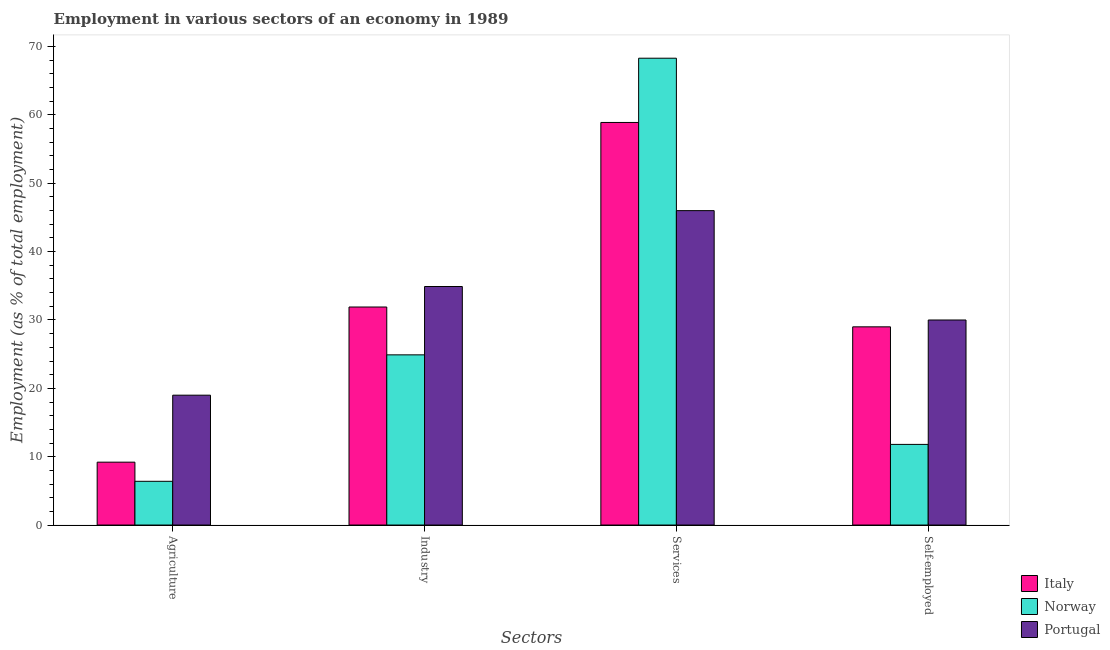Are the number of bars per tick equal to the number of legend labels?
Your response must be concise. Yes. How many bars are there on the 1st tick from the right?
Your answer should be very brief. 3. What is the label of the 3rd group of bars from the left?
Your response must be concise. Services. What is the percentage of self employed workers in Portugal?
Provide a succinct answer. 30. Across all countries, what is the maximum percentage of workers in industry?
Provide a succinct answer. 34.9. Across all countries, what is the minimum percentage of workers in agriculture?
Ensure brevity in your answer.  6.4. In which country was the percentage of workers in services maximum?
Your response must be concise. Norway. What is the total percentage of workers in industry in the graph?
Ensure brevity in your answer.  91.7. What is the difference between the percentage of workers in industry in Italy and that in Portugal?
Keep it short and to the point. -3. What is the difference between the percentage of workers in services in Portugal and the percentage of self employed workers in Italy?
Provide a short and direct response. 17. What is the average percentage of workers in agriculture per country?
Provide a short and direct response. 11.53. What is the difference between the percentage of workers in agriculture and percentage of workers in services in Portugal?
Offer a very short reply. -27. What is the ratio of the percentage of workers in industry in Norway to that in Italy?
Ensure brevity in your answer.  0.78. Is the percentage of workers in services in Norway less than that in Portugal?
Offer a terse response. No. Is the difference between the percentage of workers in agriculture in Norway and Italy greater than the difference between the percentage of workers in industry in Norway and Italy?
Make the answer very short. Yes. What is the difference between the highest and the second highest percentage of workers in services?
Offer a very short reply. 9.4. What is the difference between the highest and the lowest percentage of workers in services?
Offer a terse response. 22.3. What does the 3rd bar from the right in Agriculture represents?
Provide a short and direct response. Italy. Is it the case that in every country, the sum of the percentage of workers in agriculture and percentage of workers in industry is greater than the percentage of workers in services?
Give a very brief answer. No. What is the difference between two consecutive major ticks on the Y-axis?
Ensure brevity in your answer.  10. Are the values on the major ticks of Y-axis written in scientific E-notation?
Your response must be concise. No. Does the graph contain grids?
Your answer should be very brief. No. Where does the legend appear in the graph?
Offer a very short reply. Bottom right. What is the title of the graph?
Ensure brevity in your answer.  Employment in various sectors of an economy in 1989. What is the label or title of the X-axis?
Your answer should be very brief. Sectors. What is the label or title of the Y-axis?
Make the answer very short. Employment (as % of total employment). What is the Employment (as % of total employment) of Italy in Agriculture?
Offer a very short reply. 9.2. What is the Employment (as % of total employment) in Norway in Agriculture?
Offer a very short reply. 6.4. What is the Employment (as % of total employment) of Italy in Industry?
Offer a very short reply. 31.9. What is the Employment (as % of total employment) of Norway in Industry?
Give a very brief answer. 24.9. What is the Employment (as % of total employment) in Portugal in Industry?
Provide a short and direct response. 34.9. What is the Employment (as % of total employment) of Italy in Services?
Ensure brevity in your answer.  58.9. What is the Employment (as % of total employment) of Norway in Services?
Make the answer very short. 68.3. What is the Employment (as % of total employment) in Portugal in Services?
Provide a short and direct response. 46. What is the Employment (as % of total employment) in Italy in Self-employed?
Provide a short and direct response. 29. What is the Employment (as % of total employment) in Norway in Self-employed?
Offer a very short reply. 11.8. Across all Sectors, what is the maximum Employment (as % of total employment) of Italy?
Provide a short and direct response. 58.9. Across all Sectors, what is the maximum Employment (as % of total employment) in Norway?
Keep it short and to the point. 68.3. Across all Sectors, what is the maximum Employment (as % of total employment) of Portugal?
Offer a very short reply. 46. Across all Sectors, what is the minimum Employment (as % of total employment) of Italy?
Offer a very short reply. 9.2. Across all Sectors, what is the minimum Employment (as % of total employment) of Norway?
Keep it short and to the point. 6.4. What is the total Employment (as % of total employment) in Italy in the graph?
Provide a short and direct response. 129. What is the total Employment (as % of total employment) of Norway in the graph?
Make the answer very short. 111.4. What is the total Employment (as % of total employment) in Portugal in the graph?
Make the answer very short. 129.9. What is the difference between the Employment (as % of total employment) of Italy in Agriculture and that in Industry?
Offer a terse response. -22.7. What is the difference between the Employment (as % of total employment) of Norway in Agriculture and that in Industry?
Your response must be concise. -18.5. What is the difference between the Employment (as % of total employment) in Portugal in Agriculture and that in Industry?
Offer a very short reply. -15.9. What is the difference between the Employment (as % of total employment) in Italy in Agriculture and that in Services?
Offer a very short reply. -49.7. What is the difference between the Employment (as % of total employment) of Norway in Agriculture and that in Services?
Keep it short and to the point. -61.9. What is the difference between the Employment (as % of total employment) of Italy in Agriculture and that in Self-employed?
Your answer should be compact. -19.8. What is the difference between the Employment (as % of total employment) in Portugal in Agriculture and that in Self-employed?
Your answer should be compact. -11. What is the difference between the Employment (as % of total employment) of Norway in Industry and that in Services?
Offer a very short reply. -43.4. What is the difference between the Employment (as % of total employment) in Portugal in Industry and that in Services?
Your answer should be compact. -11.1. What is the difference between the Employment (as % of total employment) in Italy in Industry and that in Self-employed?
Provide a short and direct response. 2.9. What is the difference between the Employment (as % of total employment) in Italy in Services and that in Self-employed?
Offer a very short reply. 29.9. What is the difference between the Employment (as % of total employment) of Norway in Services and that in Self-employed?
Offer a terse response. 56.5. What is the difference between the Employment (as % of total employment) of Portugal in Services and that in Self-employed?
Offer a terse response. 16. What is the difference between the Employment (as % of total employment) of Italy in Agriculture and the Employment (as % of total employment) of Norway in Industry?
Make the answer very short. -15.7. What is the difference between the Employment (as % of total employment) in Italy in Agriculture and the Employment (as % of total employment) in Portugal in Industry?
Keep it short and to the point. -25.7. What is the difference between the Employment (as % of total employment) of Norway in Agriculture and the Employment (as % of total employment) of Portugal in Industry?
Your response must be concise. -28.5. What is the difference between the Employment (as % of total employment) in Italy in Agriculture and the Employment (as % of total employment) in Norway in Services?
Offer a terse response. -59.1. What is the difference between the Employment (as % of total employment) of Italy in Agriculture and the Employment (as % of total employment) of Portugal in Services?
Your response must be concise. -36.8. What is the difference between the Employment (as % of total employment) of Norway in Agriculture and the Employment (as % of total employment) of Portugal in Services?
Provide a succinct answer. -39.6. What is the difference between the Employment (as % of total employment) of Italy in Agriculture and the Employment (as % of total employment) of Norway in Self-employed?
Ensure brevity in your answer.  -2.6. What is the difference between the Employment (as % of total employment) in Italy in Agriculture and the Employment (as % of total employment) in Portugal in Self-employed?
Your answer should be very brief. -20.8. What is the difference between the Employment (as % of total employment) in Norway in Agriculture and the Employment (as % of total employment) in Portugal in Self-employed?
Provide a short and direct response. -23.6. What is the difference between the Employment (as % of total employment) of Italy in Industry and the Employment (as % of total employment) of Norway in Services?
Ensure brevity in your answer.  -36.4. What is the difference between the Employment (as % of total employment) of Italy in Industry and the Employment (as % of total employment) of Portugal in Services?
Your answer should be compact. -14.1. What is the difference between the Employment (as % of total employment) in Norway in Industry and the Employment (as % of total employment) in Portugal in Services?
Your response must be concise. -21.1. What is the difference between the Employment (as % of total employment) in Italy in Industry and the Employment (as % of total employment) in Norway in Self-employed?
Offer a very short reply. 20.1. What is the difference between the Employment (as % of total employment) in Italy in Services and the Employment (as % of total employment) in Norway in Self-employed?
Keep it short and to the point. 47.1. What is the difference between the Employment (as % of total employment) in Italy in Services and the Employment (as % of total employment) in Portugal in Self-employed?
Provide a short and direct response. 28.9. What is the difference between the Employment (as % of total employment) in Norway in Services and the Employment (as % of total employment) in Portugal in Self-employed?
Offer a very short reply. 38.3. What is the average Employment (as % of total employment) in Italy per Sectors?
Provide a short and direct response. 32.25. What is the average Employment (as % of total employment) in Norway per Sectors?
Keep it short and to the point. 27.85. What is the average Employment (as % of total employment) of Portugal per Sectors?
Your answer should be very brief. 32.48. What is the difference between the Employment (as % of total employment) in Italy and Employment (as % of total employment) in Portugal in Agriculture?
Ensure brevity in your answer.  -9.8. What is the difference between the Employment (as % of total employment) in Italy and Employment (as % of total employment) in Norway in Industry?
Your answer should be very brief. 7. What is the difference between the Employment (as % of total employment) of Norway and Employment (as % of total employment) of Portugal in Industry?
Offer a terse response. -10. What is the difference between the Employment (as % of total employment) of Italy and Employment (as % of total employment) of Portugal in Services?
Ensure brevity in your answer.  12.9. What is the difference between the Employment (as % of total employment) in Norway and Employment (as % of total employment) in Portugal in Services?
Ensure brevity in your answer.  22.3. What is the difference between the Employment (as % of total employment) in Norway and Employment (as % of total employment) in Portugal in Self-employed?
Your response must be concise. -18.2. What is the ratio of the Employment (as % of total employment) in Italy in Agriculture to that in Industry?
Keep it short and to the point. 0.29. What is the ratio of the Employment (as % of total employment) in Norway in Agriculture to that in Industry?
Your answer should be very brief. 0.26. What is the ratio of the Employment (as % of total employment) in Portugal in Agriculture to that in Industry?
Offer a very short reply. 0.54. What is the ratio of the Employment (as % of total employment) in Italy in Agriculture to that in Services?
Your answer should be very brief. 0.16. What is the ratio of the Employment (as % of total employment) in Norway in Agriculture to that in Services?
Ensure brevity in your answer.  0.09. What is the ratio of the Employment (as % of total employment) in Portugal in Agriculture to that in Services?
Your answer should be very brief. 0.41. What is the ratio of the Employment (as % of total employment) of Italy in Agriculture to that in Self-employed?
Offer a terse response. 0.32. What is the ratio of the Employment (as % of total employment) in Norway in Agriculture to that in Self-employed?
Make the answer very short. 0.54. What is the ratio of the Employment (as % of total employment) of Portugal in Agriculture to that in Self-employed?
Make the answer very short. 0.63. What is the ratio of the Employment (as % of total employment) of Italy in Industry to that in Services?
Provide a succinct answer. 0.54. What is the ratio of the Employment (as % of total employment) of Norway in Industry to that in Services?
Give a very brief answer. 0.36. What is the ratio of the Employment (as % of total employment) in Portugal in Industry to that in Services?
Your response must be concise. 0.76. What is the ratio of the Employment (as % of total employment) of Norway in Industry to that in Self-employed?
Provide a succinct answer. 2.11. What is the ratio of the Employment (as % of total employment) in Portugal in Industry to that in Self-employed?
Ensure brevity in your answer.  1.16. What is the ratio of the Employment (as % of total employment) of Italy in Services to that in Self-employed?
Your answer should be compact. 2.03. What is the ratio of the Employment (as % of total employment) of Norway in Services to that in Self-employed?
Your response must be concise. 5.79. What is the ratio of the Employment (as % of total employment) of Portugal in Services to that in Self-employed?
Ensure brevity in your answer.  1.53. What is the difference between the highest and the second highest Employment (as % of total employment) of Norway?
Your response must be concise. 43.4. What is the difference between the highest and the lowest Employment (as % of total employment) of Italy?
Give a very brief answer. 49.7. What is the difference between the highest and the lowest Employment (as % of total employment) of Norway?
Make the answer very short. 61.9. What is the difference between the highest and the lowest Employment (as % of total employment) in Portugal?
Ensure brevity in your answer.  27. 